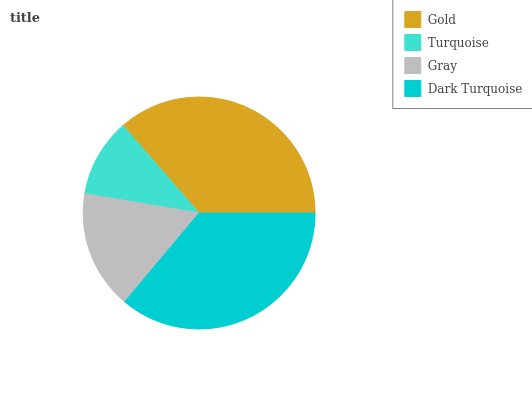Is Turquoise the minimum?
Answer yes or no. Yes. Is Gold the maximum?
Answer yes or no. Yes. Is Gray the minimum?
Answer yes or no. No. Is Gray the maximum?
Answer yes or no. No. Is Gray greater than Turquoise?
Answer yes or no. Yes. Is Turquoise less than Gray?
Answer yes or no. Yes. Is Turquoise greater than Gray?
Answer yes or no. No. Is Gray less than Turquoise?
Answer yes or no. No. Is Dark Turquoise the high median?
Answer yes or no. Yes. Is Gray the low median?
Answer yes or no. Yes. Is Turquoise the high median?
Answer yes or no. No. Is Turquoise the low median?
Answer yes or no. No. 